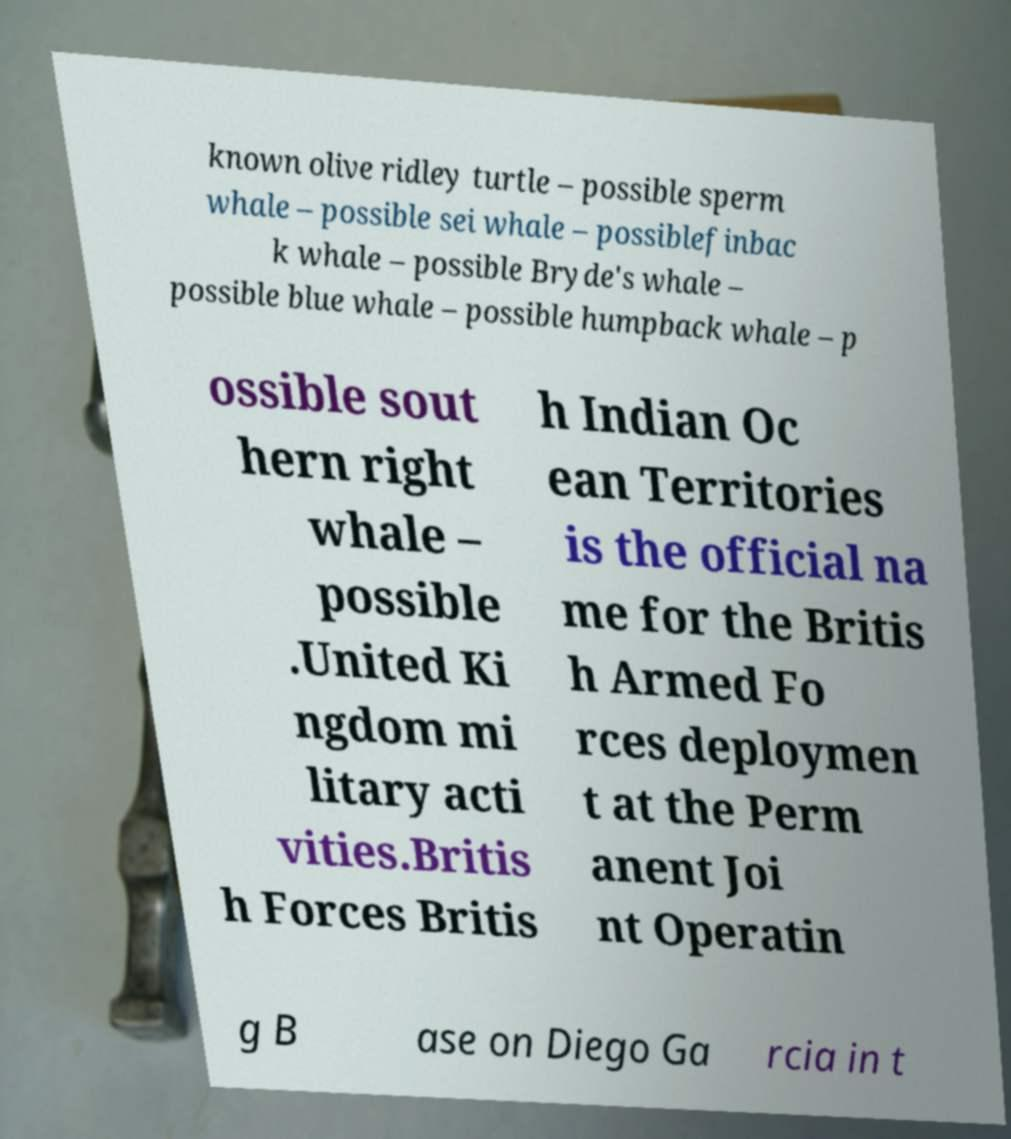Can you read and provide the text displayed in the image?This photo seems to have some interesting text. Can you extract and type it out for me? known olive ridley turtle – possible sperm whale – possible sei whale – possiblefinbac k whale – possible Bryde's whale – possible blue whale – possible humpback whale – p ossible sout hern right whale – possible .United Ki ngdom mi litary acti vities.Britis h Forces Britis h Indian Oc ean Territories is the official na me for the Britis h Armed Fo rces deploymen t at the Perm anent Joi nt Operatin g B ase on Diego Ga rcia in t 